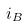<formula> <loc_0><loc_0><loc_500><loc_500>i _ { B }</formula> 